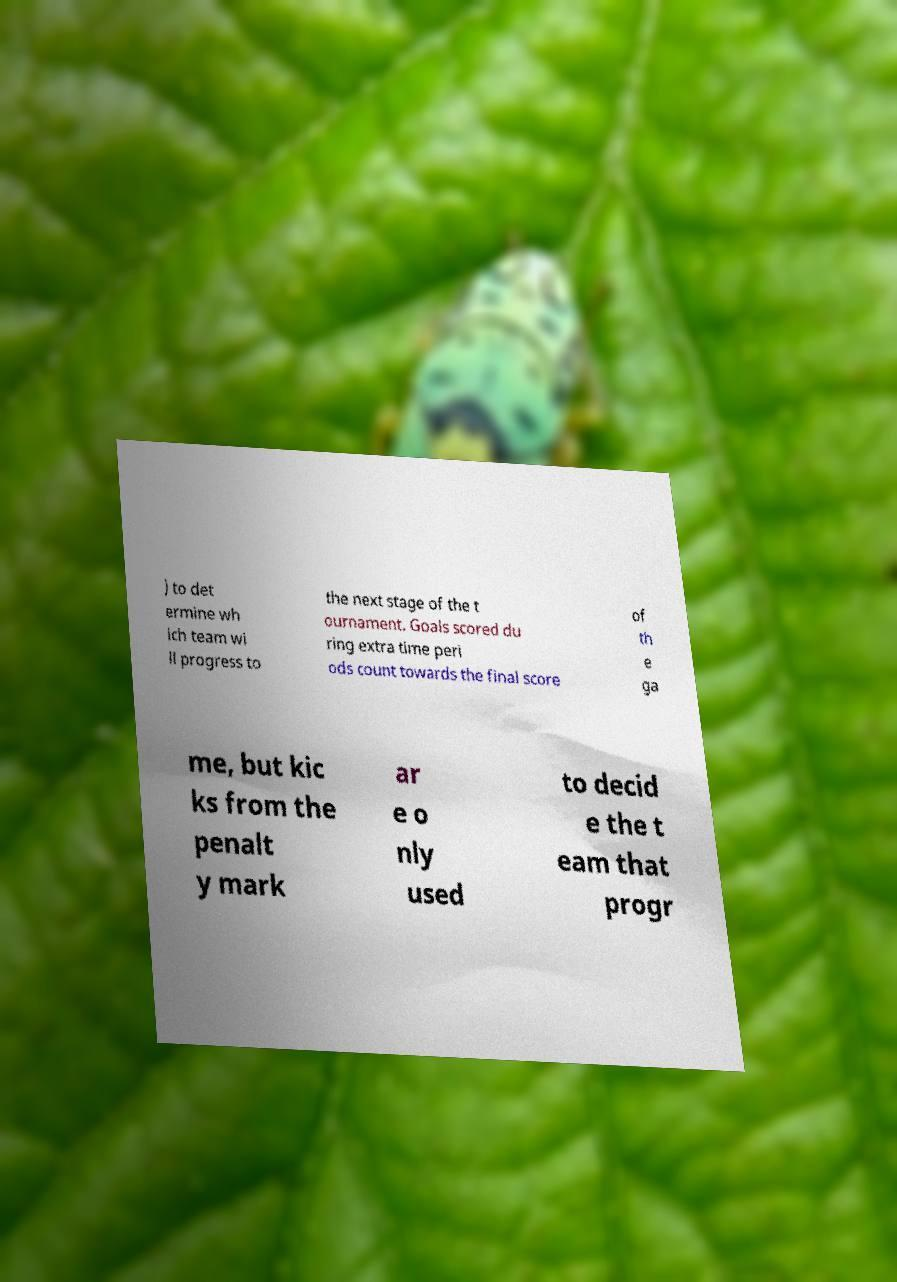Could you extract and type out the text from this image? ) to det ermine wh ich team wi ll progress to the next stage of the t ournament. Goals scored du ring extra time peri ods count towards the final score of th e ga me, but kic ks from the penalt y mark ar e o nly used to decid e the t eam that progr 